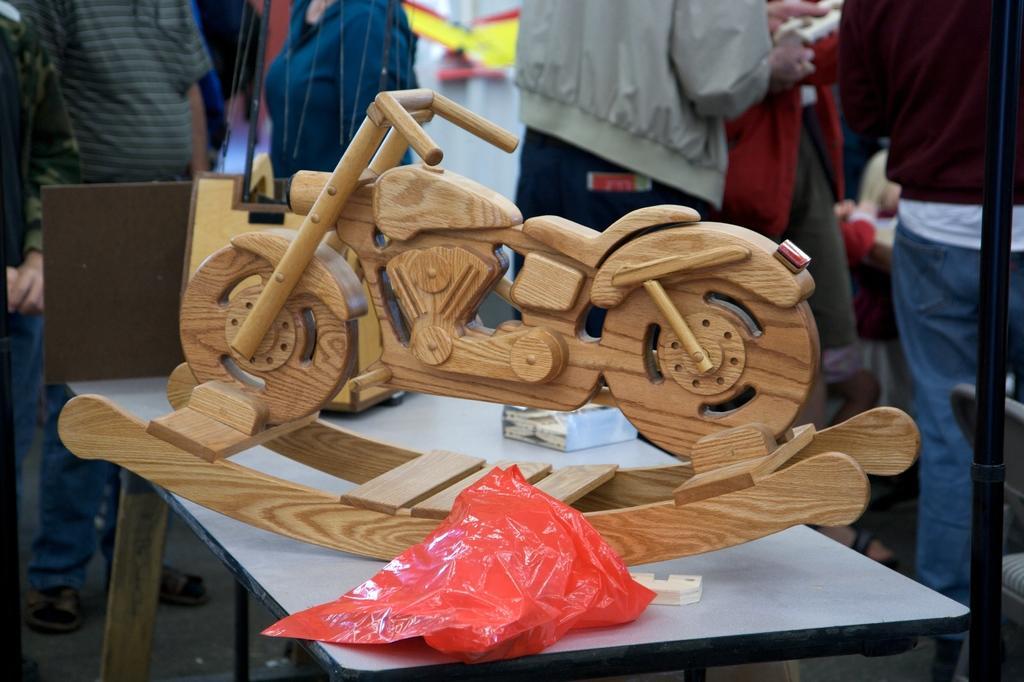Can you describe this image briefly? In the image there is a table. On the table there is a wooden toy bike and also there is a red cover. In the background there are few people standing. On the right side of the image there is a rod. 